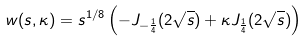<formula> <loc_0><loc_0><loc_500><loc_500>w ( s , \kappa ) = s ^ { 1 / 8 } \left ( - J _ { - \frac { 1 } { 4 } } ( 2 \sqrt { s } ) + { \kappa } J _ { \frac { 1 } { 4 } } ( 2 \sqrt { s } ) \right )</formula> 